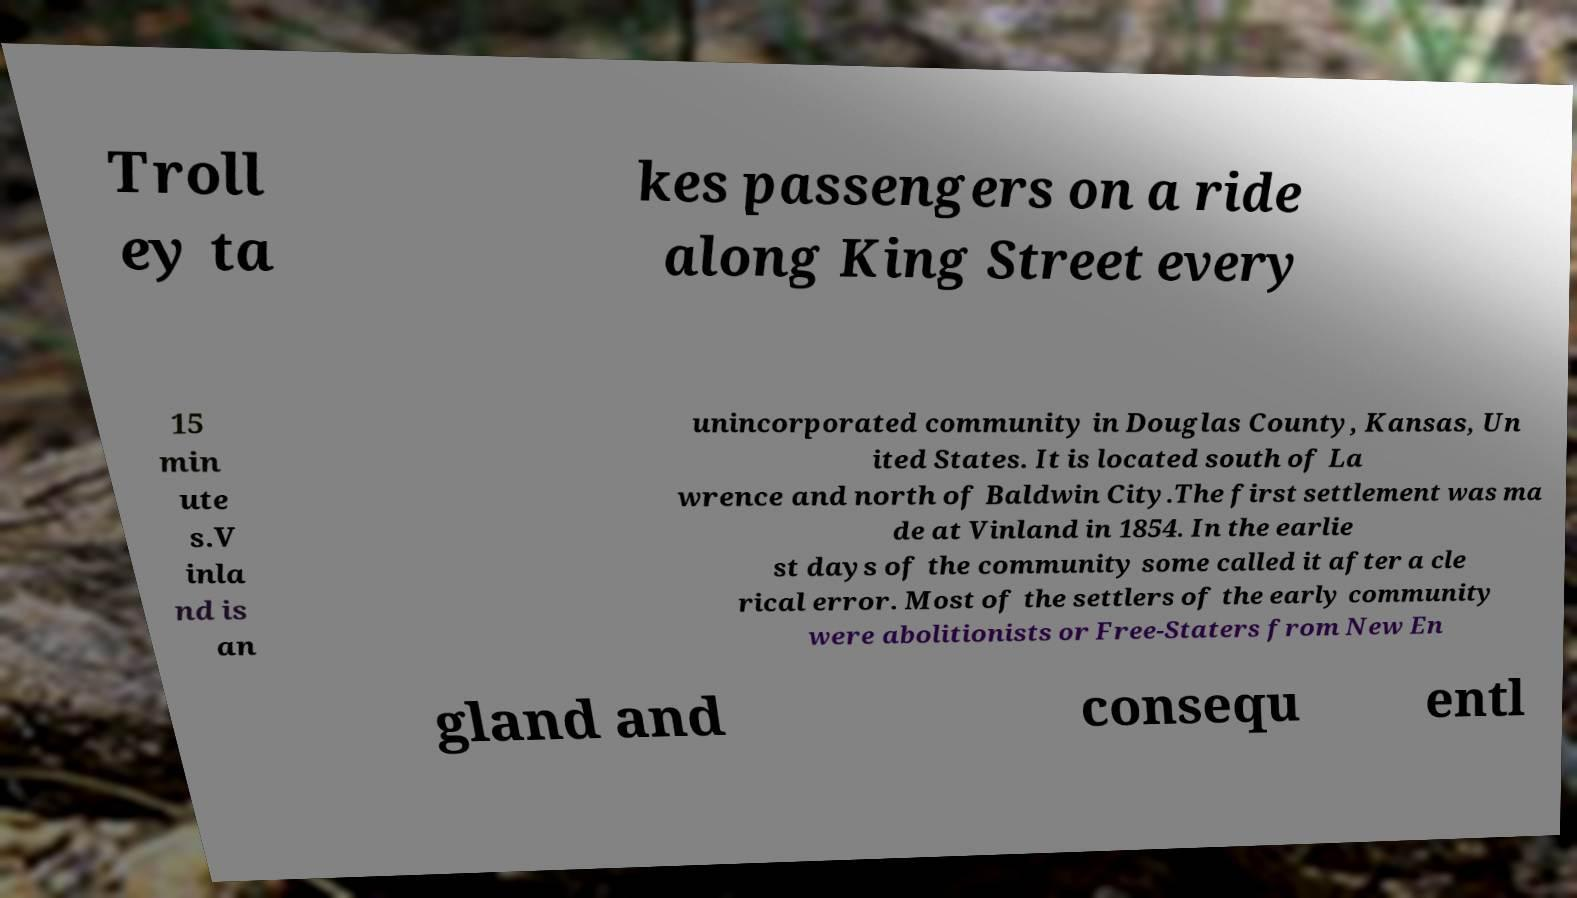Please identify and transcribe the text found in this image. Troll ey ta kes passengers on a ride along King Street every 15 min ute s.V inla nd is an unincorporated community in Douglas County, Kansas, Un ited States. It is located south of La wrence and north of Baldwin City.The first settlement was ma de at Vinland in 1854. In the earlie st days of the community some called it after a cle rical error. Most of the settlers of the early community were abolitionists or Free-Staters from New En gland and consequ entl 